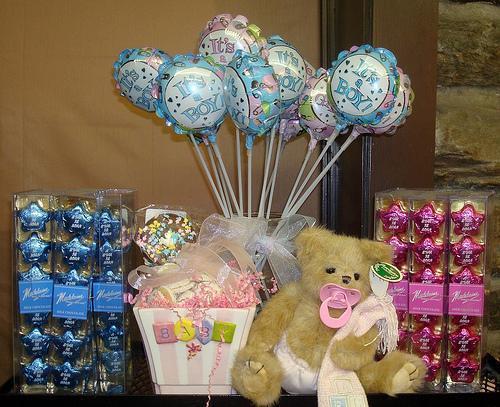How many bears are in the picture?
Give a very brief answer. 1. 